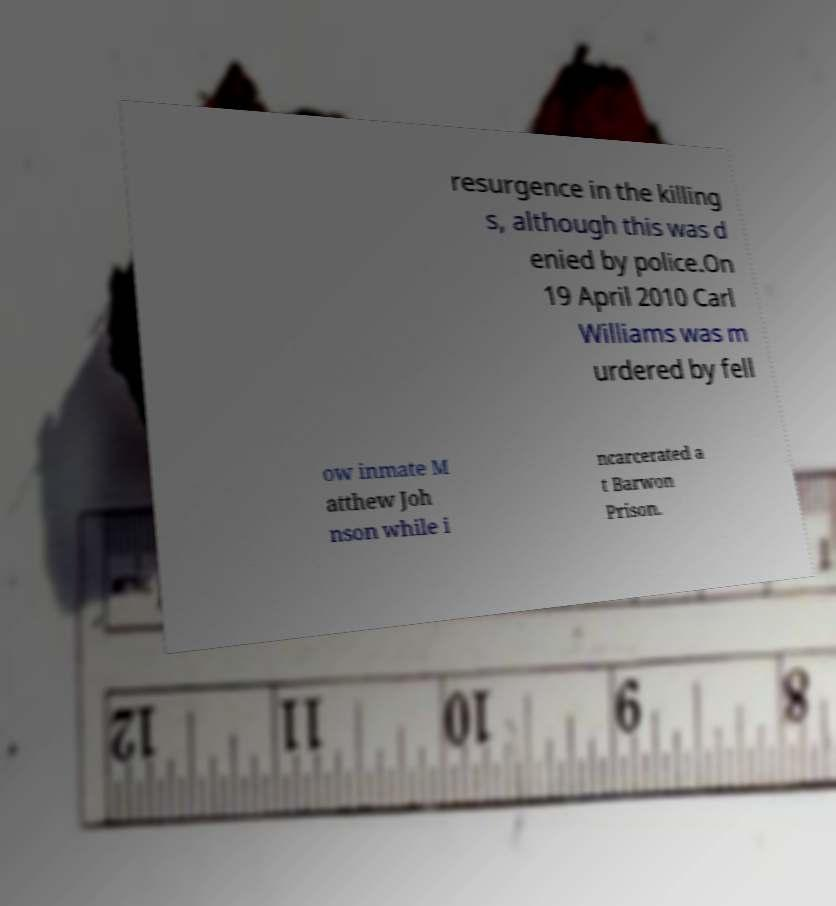Please identify and transcribe the text found in this image. resurgence in the killing s, although this was d enied by police.On 19 April 2010 Carl Williams was m urdered by fell ow inmate M atthew Joh nson while i ncarcerated a t Barwon Prison. 